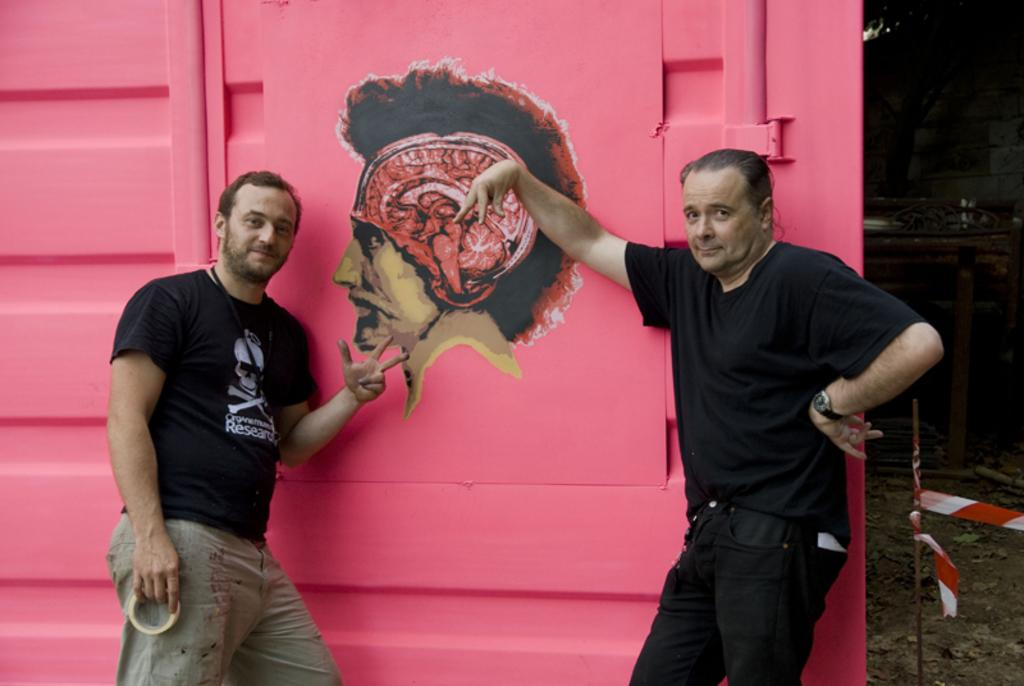How many people are in the image? There are two men in the image. What is the color of the background in the image? The background in the image is pink. What are the men doing in the image? The men are posing for a photo. Is there any other image or object on the pink background? Yes, there is an image of a man on the pink background. What type of bottle can be seen hanging from the branch in the image? There is no bottle or branch present in the image. 